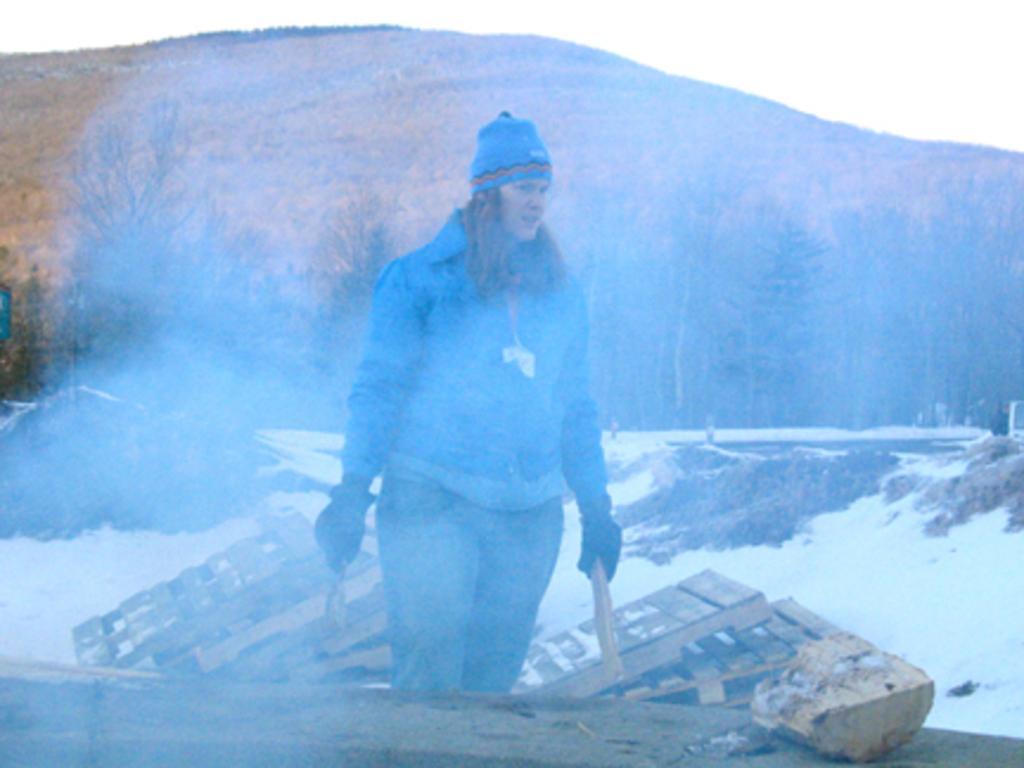Can you describe this image briefly? In the center of the image, we can see a lady wearing a coat and a cap and gloves and holding some objects. At the bottom, there is wood and we can see snow. In the background, there are trees and there is a hill. 